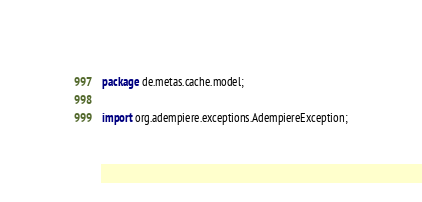<code> <loc_0><loc_0><loc_500><loc_500><_Java_>package de.metas.cache.model;

import org.adempiere.exceptions.AdempiereException;</code> 